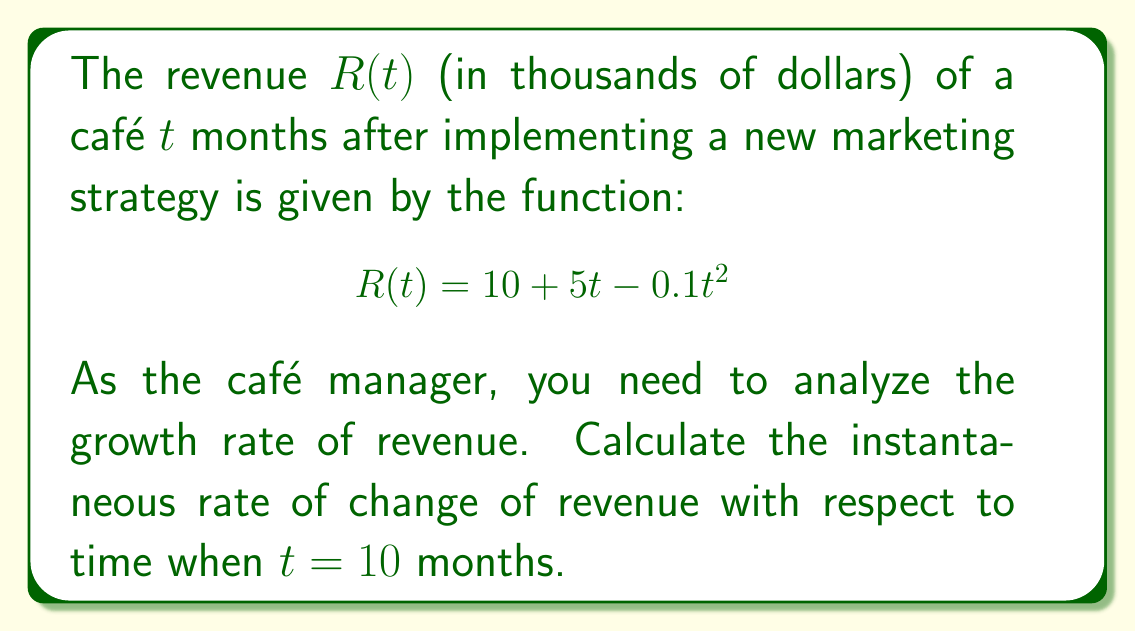Show me your answer to this math problem. To find the instantaneous rate of change of revenue with respect to time, we need to calculate the derivative of the revenue function $R(t)$ and then evaluate it at $t = 10$ months.

1. Given revenue function:
   $$R(t) = 10 + 5t - 0.1t^2$$

2. Calculate the derivative $R'(t)$:
   $$R'(t) = \frac{d}{dt}(10 + 5t - 0.1t^2)$$
   $$R'(t) = 0 + 5 - 0.2t$$
   $$R'(t) = 5 - 0.2t$$

3. Evaluate $R'(t)$ at $t = 10$:
   $$R'(10) = 5 - 0.2(10)$$
   $$R'(10) = 5 - 2$$
   $$R'(10) = 3$$

The instantaneous rate of change of revenue with respect to time when $t = 10$ months is 3 thousand dollars per month.

This means that at the 10-month mark, the café's revenue is growing at a rate of $3,000 per month.
Answer: $3$ thousand dollars per month 